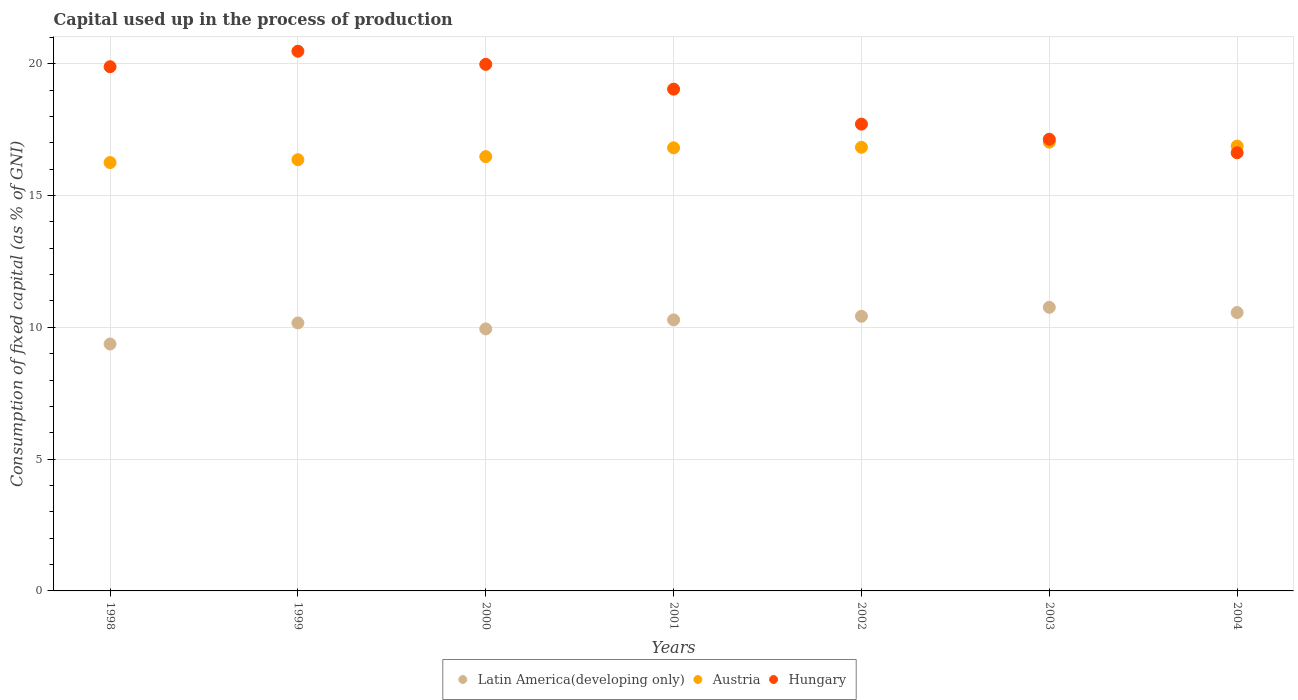How many different coloured dotlines are there?
Give a very brief answer. 3. Is the number of dotlines equal to the number of legend labels?
Ensure brevity in your answer.  Yes. What is the capital used up in the process of production in Austria in 1998?
Give a very brief answer. 16.25. Across all years, what is the maximum capital used up in the process of production in Hungary?
Your response must be concise. 20.47. Across all years, what is the minimum capital used up in the process of production in Austria?
Give a very brief answer. 16.25. In which year was the capital used up in the process of production in Latin America(developing only) minimum?
Your answer should be compact. 1998. What is the total capital used up in the process of production in Latin America(developing only) in the graph?
Make the answer very short. 71.49. What is the difference between the capital used up in the process of production in Hungary in 1999 and that in 2002?
Your response must be concise. 2.77. What is the difference between the capital used up in the process of production in Austria in 2002 and the capital used up in the process of production in Latin America(developing only) in 1999?
Provide a succinct answer. 6.66. What is the average capital used up in the process of production in Hungary per year?
Make the answer very short. 18.69. In the year 2003, what is the difference between the capital used up in the process of production in Austria and capital used up in the process of production in Latin America(developing only)?
Offer a very short reply. 6.27. In how many years, is the capital used up in the process of production in Latin America(developing only) greater than 6 %?
Make the answer very short. 7. What is the ratio of the capital used up in the process of production in Austria in 2000 to that in 2002?
Ensure brevity in your answer.  0.98. Is the capital used up in the process of production in Hungary in 2000 less than that in 2003?
Make the answer very short. No. What is the difference between the highest and the second highest capital used up in the process of production in Hungary?
Provide a succinct answer. 0.5. What is the difference between the highest and the lowest capital used up in the process of production in Austria?
Offer a terse response. 0.77. In how many years, is the capital used up in the process of production in Latin America(developing only) greater than the average capital used up in the process of production in Latin America(developing only) taken over all years?
Give a very brief answer. 4. Is it the case that in every year, the sum of the capital used up in the process of production in Austria and capital used up in the process of production in Latin America(developing only)  is greater than the capital used up in the process of production in Hungary?
Make the answer very short. Yes. How many legend labels are there?
Keep it short and to the point. 3. How are the legend labels stacked?
Offer a very short reply. Horizontal. What is the title of the graph?
Your answer should be compact. Capital used up in the process of production. Does "Least developed countries" appear as one of the legend labels in the graph?
Your response must be concise. No. What is the label or title of the X-axis?
Provide a short and direct response. Years. What is the label or title of the Y-axis?
Provide a short and direct response. Consumption of fixed capital (as % of GNI). What is the Consumption of fixed capital (as % of GNI) in Latin America(developing only) in 1998?
Offer a terse response. 9.37. What is the Consumption of fixed capital (as % of GNI) of Austria in 1998?
Give a very brief answer. 16.25. What is the Consumption of fixed capital (as % of GNI) in Hungary in 1998?
Ensure brevity in your answer.  19.89. What is the Consumption of fixed capital (as % of GNI) of Latin America(developing only) in 1999?
Offer a very short reply. 10.17. What is the Consumption of fixed capital (as % of GNI) in Austria in 1999?
Make the answer very short. 16.36. What is the Consumption of fixed capital (as % of GNI) in Hungary in 1999?
Your answer should be compact. 20.47. What is the Consumption of fixed capital (as % of GNI) of Latin America(developing only) in 2000?
Make the answer very short. 9.94. What is the Consumption of fixed capital (as % of GNI) in Austria in 2000?
Provide a short and direct response. 16.48. What is the Consumption of fixed capital (as % of GNI) of Hungary in 2000?
Ensure brevity in your answer.  19.98. What is the Consumption of fixed capital (as % of GNI) of Latin America(developing only) in 2001?
Your answer should be compact. 10.28. What is the Consumption of fixed capital (as % of GNI) in Austria in 2001?
Offer a terse response. 16.81. What is the Consumption of fixed capital (as % of GNI) in Hungary in 2001?
Make the answer very short. 19.04. What is the Consumption of fixed capital (as % of GNI) in Latin America(developing only) in 2002?
Make the answer very short. 10.42. What is the Consumption of fixed capital (as % of GNI) in Austria in 2002?
Provide a succinct answer. 16.83. What is the Consumption of fixed capital (as % of GNI) of Hungary in 2002?
Give a very brief answer. 17.71. What is the Consumption of fixed capital (as % of GNI) in Latin America(developing only) in 2003?
Ensure brevity in your answer.  10.76. What is the Consumption of fixed capital (as % of GNI) of Austria in 2003?
Keep it short and to the point. 17.02. What is the Consumption of fixed capital (as % of GNI) of Hungary in 2003?
Keep it short and to the point. 17.14. What is the Consumption of fixed capital (as % of GNI) in Latin America(developing only) in 2004?
Provide a short and direct response. 10.56. What is the Consumption of fixed capital (as % of GNI) in Austria in 2004?
Make the answer very short. 16.88. What is the Consumption of fixed capital (as % of GNI) in Hungary in 2004?
Offer a very short reply. 16.62. Across all years, what is the maximum Consumption of fixed capital (as % of GNI) in Latin America(developing only)?
Make the answer very short. 10.76. Across all years, what is the maximum Consumption of fixed capital (as % of GNI) in Austria?
Offer a terse response. 17.02. Across all years, what is the maximum Consumption of fixed capital (as % of GNI) in Hungary?
Make the answer very short. 20.47. Across all years, what is the minimum Consumption of fixed capital (as % of GNI) in Latin America(developing only)?
Provide a short and direct response. 9.37. Across all years, what is the minimum Consumption of fixed capital (as % of GNI) of Austria?
Keep it short and to the point. 16.25. Across all years, what is the minimum Consumption of fixed capital (as % of GNI) of Hungary?
Your answer should be very brief. 16.62. What is the total Consumption of fixed capital (as % of GNI) in Latin America(developing only) in the graph?
Give a very brief answer. 71.49. What is the total Consumption of fixed capital (as % of GNI) of Austria in the graph?
Offer a very short reply. 116.62. What is the total Consumption of fixed capital (as % of GNI) in Hungary in the graph?
Ensure brevity in your answer.  130.84. What is the difference between the Consumption of fixed capital (as % of GNI) of Latin America(developing only) in 1998 and that in 1999?
Your response must be concise. -0.8. What is the difference between the Consumption of fixed capital (as % of GNI) in Austria in 1998 and that in 1999?
Make the answer very short. -0.11. What is the difference between the Consumption of fixed capital (as % of GNI) in Hungary in 1998 and that in 1999?
Keep it short and to the point. -0.59. What is the difference between the Consumption of fixed capital (as % of GNI) in Latin America(developing only) in 1998 and that in 2000?
Make the answer very short. -0.57. What is the difference between the Consumption of fixed capital (as % of GNI) in Austria in 1998 and that in 2000?
Your answer should be compact. -0.22. What is the difference between the Consumption of fixed capital (as % of GNI) in Hungary in 1998 and that in 2000?
Your response must be concise. -0.09. What is the difference between the Consumption of fixed capital (as % of GNI) in Latin America(developing only) in 1998 and that in 2001?
Your answer should be compact. -0.91. What is the difference between the Consumption of fixed capital (as % of GNI) in Austria in 1998 and that in 2001?
Keep it short and to the point. -0.56. What is the difference between the Consumption of fixed capital (as % of GNI) of Hungary in 1998 and that in 2001?
Your answer should be very brief. 0.85. What is the difference between the Consumption of fixed capital (as % of GNI) of Latin America(developing only) in 1998 and that in 2002?
Keep it short and to the point. -1.05. What is the difference between the Consumption of fixed capital (as % of GNI) in Austria in 1998 and that in 2002?
Keep it short and to the point. -0.58. What is the difference between the Consumption of fixed capital (as % of GNI) of Hungary in 1998 and that in 2002?
Provide a succinct answer. 2.18. What is the difference between the Consumption of fixed capital (as % of GNI) of Latin America(developing only) in 1998 and that in 2003?
Your answer should be very brief. -1.39. What is the difference between the Consumption of fixed capital (as % of GNI) in Austria in 1998 and that in 2003?
Provide a succinct answer. -0.77. What is the difference between the Consumption of fixed capital (as % of GNI) in Hungary in 1998 and that in 2003?
Provide a short and direct response. 2.75. What is the difference between the Consumption of fixed capital (as % of GNI) of Latin America(developing only) in 1998 and that in 2004?
Ensure brevity in your answer.  -1.19. What is the difference between the Consumption of fixed capital (as % of GNI) in Austria in 1998 and that in 2004?
Your answer should be very brief. -0.62. What is the difference between the Consumption of fixed capital (as % of GNI) in Hungary in 1998 and that in 2004?
Keep it short and to the point. 3.26. What is the difference between the Consumption of fixed capital (as % of GNI) in Latin America(developing only) in 1999 and that in 2000?
Your answer should be very brief. 0.23. What is the difference between the Consumption of fixed capital (as % of GNI) of Austria in 1999 and that in 2000?
Your response must be concise. -0.12. What is the difference between the Consumption of fixed capital (as % of GNI) of Hungary in 1999 and that in 2000?
Provide a short and direct response. 0.5. What is the difference between the Consumption of fixed capital (as % of GNI) of Latin America(developing only) in 1999 and that in 2001?
Provide a short and direct response. -0.12. What is the difference between the Consumption of fixed capital (as % of GNI) in Austria in 1999 and that in 2001?
Offer a very short reply. -0.45. What is the difference between the Consumption of fixed capital (as % of GNI) in Hungary in 1999 and that in 2001?
Provide a short and direct response. 1.44. What is the difference between the Consumption of fixed capital (as % of GNI) in Latin America(developing only) in 1999 and that in 2002?
Ensure brevity in your answer.  -0.25. What is the difference between the Consumption of fixed capital (as % of GNI) in Austria in 1999 and that in 2002?
Your answer should be compact. -0.47. What is the difference between the Consumption of fixed capital (as % of GNI) of Hungary in 1999 and that in 2002?
Give a very brief answer. 2.77. What is the difference between the Consumption of fixed capital (as % of GNI) in Latin America(developing only) in 1999 and that in 2003?
Ensure brevity in your answer.  -0.59. What is the difference between the Consumption of fixed capital (as % of GNI) of Austria in 1999 and that in 2003?
Keep it short and to the point. -0.67. What is the difference between the Consumption of fixed capital (as % of GNI) of Hungary in 1999 and that in 2003?
Offer a very short reply. 3.34. What is the difference between the Consumption of fixed capital (as % of GNI) in Latin America(developing only) in 1999 and that in 2004?
Ensure brevity in your answer.  -0.39. What is the difference between the Consumption of fixed capital (as % of GNI) in Austria in 1999 and that in 2004?
Your answer should be compact. -0.52. What is the difference between the Consumption of fixed capital (as % of GNI) in Hungary in 1999 and that in 2004?
Make the answer very short. 3.85. What is the difference between the Consumption of fixed capital (as % of GNI) of Latin America(developing only) in 2000 and that in 2001?
Your answer should be compact. -0.34. What is the difference between the Consumption of fixed capital (as % of GNI) of Austria in 2000 and that in 2001?
Give a very brief answer. -0.33. What is the difference between the Consumption of fixed capital (as % of GNI) in Hungary in 2000 and that in 2001?
Give a very brief answer. 0.94. What is the difference between the Consumption of fixed capital (as % of GNI) of Latin America(developing only) in 2000 and that in 2002?
Your answer should be compact. -0.48. What is the difference between the Consumption of fixed capital (as % of GNI) in Austria in 2000 and that in 2002?
Provide a short and direct response. -0.35. What is the difference between the Consumption of fixed capital (as % of GNI) of Hungary in 2000 and that in 2002?
Give a very brief answer. 2.27. What is the difference between the Consumption of fixed capital (as % of GNI) of Latin America(developing only) in 2000 and that in 2003?
Your answer should be compact. -0.82. What is the difference between the Consumption of fixed capital (as % of GNI) in Austria in 2000 and that in 2003?
Your response must be concise. -0.55. What is the difference between the Consumption of fixed capital (as % of GNI) of Hungary in 2000 and that in 2003?
Offer a terse response. 2.84. What is the difference between the Consumption of fixed capital (as % of GNI) in Latin America(developing only) in 2000 and that in 2004?
Provide a succinct answer. -0.62. What is the difference between the Consumption of fixed capital (as % of GNI) of Austria in 2000 and that in 2004?
Make the answer very short. -0.4. What is the difference between the Consumption of fixed capital (as % of GNI) of Hungary in 2000 and that in 2004?
Make the answer very short. 3.35. What is the difference between the Consumption of fixed capital (as % of GNI) in Latin America(developing only) in 2001 and that in 2002?
Offer a very short reply. -0.14. What is the difference between the Consumption of fixed capital (as % of GNI) of Austria in 2001 and that in 2002?
Offer a terse response. -0.02. What is the difference between the Consumption of fixed capital (as % of GNI) of Hungary in 2001 and that in 2002?
Your response must be concise. 1.33. What is the difference between the Consumption of fixed capital (as % of GNI) of Latin America(developing only) in 2001 and that in 2003?
Give a very brief answer. -0.48. What is the difference between the Consumption of fixed capital (as % of GNI) of Austria in 2001 and that in 2003?
Keep it short and to the point. -0.21. What is the difference between the Consumption of fixed capital (as % of GNI) in Hungary in 2001 and that in 2003?
Provide a succinct answer. 1.9. What is the difference between the Consumption of fixed capital (as % of GNI) of Latin America(developing only) in 2001 and that in 2004?
Keep it short and to the point. -0.28. What is the difference between the Consumption of fixed capital (as % of GNI) in Austria in 2001 and that in 2004?
Make the answer very short. -0.07. What is the difference between the Consumption of fixed capital (as % of GNI) of Hungary in 2001 and that in 2004?
Give a very brief answer. 2.41. What is the difference between the Consumption of fixed capital (as % of GNI) of Latin America(developing only) in 2002 and that in 2003?
Your answer should be very brief. -0.34. What is the difference between the Consumption of fixed capital (as % of GNI) of Austria in 2002 and that in 2003?
Provide a succinct answer. -0.19. What is the difference between the Consumption of fixed capital (as % of GNI) in Hungary in 2002 and that in 2003?
Your response must be concise. 0.57. What is the difference between the Consumption of fixed capital (as % of GNI) of Latin America(developing only) in 2002 and that in 2004?
Ensure brevity in your answer.  -0.14. What is the difference between the Consumption of fixed capital (as % of GNI) of Austria in 2002 and that in 2004?
Make the answer very short. -0.05. What is the difference between the Consumption of fixed capital (as % of GNI) of Hungary in 2002 and that in 2004?
Make the answer very short. 1.09. What is the difference between the Consumption of fixed capital (as % of GNI) of Latin America(developing only) in 2003 and that in 2004?
Your answer should be very brief. 0.2. What is the difference between the Consumption of fixed capital (as % of GNI) of Austria in 2003 and that in 2004?
Give a very brief answer. 0.15. What is the difference between the Consumption of fixed capital (as % of GNI) of Hungary in 2003 and that in 2004?
Your response must be concise. 0.51. What is the difference between the Consumption of fixed capital (as % of GNI) in Latin America(developing only) in 1998 and the Consumption of fixed capital (as % of GNI) in Austria in 1999?
Make the answer very short. -6.99. What is the difference between the Consumption of fixed capital (as % of GNI) in Latin America(developing only) in 1998 and the Consumption of fixed capital (as % of GNI) in Hungary in 1999?
Provide a short and direct response. -11.11. What is the difference between the Consumption of fixed capital (as % of GNI) in Austria in 1998 and the Consumption of fixed capital (as % of GNI) in Hungary in 1999?
Provide a succinct answer. -4.22. What is the difference between the Consumption of fixed capital (as % of GNI) in Latin America(developing only) in 1998 and the Consumption of fixed capital (as % of GNI) in Austria in 2000?
Offer a terse response. -7.11. What is the difference between the Consumption of fixed capital (as % of GNI) in Latin America(developing only) in 1998 and the Consumption of fixed capital (as % of GNI) in Hungary in 2000?
Ensure brevity in your answer.  -10.61. What is the difference between the Consumption of fixed capital (as % of GNI) of Austria in 1998 and the Consumption of fixed capital (as % of GNI) of Hungary in 2000?
Your answer should be very brief. -3.73. What is the difference between the Consumption of fixed capital (as % of GNI) in Latin America(developing only) in 1998 and the Consumption of fixed capital (as % of GNI) in Austria in 2001?
Your answer should be compact. -7.44. What is the difference between the Consumption of fixed capital (as % of GNI) of Latin America(developing only) in 1998 and the Consumption of fixed capital (as % of GNI) of Hungary in 2001?
Your answer should be very brief. -9.67. What is the difference between the Consumption of fixed capital (as % of GNI) of Austria in 1998 and the Consumption of fixed capital (as % of GNI) of Hungary in 2001?
Offer a very short reply. -2.78. What is the difference between the Consumption of fixed capital (as % of GNI) in Latin America(developing only) in 1998 and the Consumption of fixed capital (as % of GNI) in Austria in 2002?
Provide a succinct answer. -7.46. What is the difference between the Consumption of fixed capital (as % of GNI) of Latin America(developing only) in 1998 and the Consumption of fixed capital (as % of GNI) of Hungary in 2002?
Your response must be concise. -8.34. What is the difference between the Consumption of fixed capital (as % of GNI) in Austria in 1998 and the Consumption of fixed capital (as % of GNI) in Hungary in 2002?
Provide a short and direct response. -1.46. What is the difference between the Consumption of fixed capital (as % of GNI) in Latin America(developing only) in 1998 and the Consumption of fixed capital (as % of GNI) in Austria in 2003?
Offer a terse response. -7.66. What is the difference between the Consumption of fixed capital (as % of GNI) of Latin America(developing only) in 1998 and the Consumption of fixed capital (as % of GNI) of Hungary in 2003?
Give a very brief answer. -7.77. What is the difference between the Consumption of fixed capital (as % of GNI) in Austria in 1998 and the Consumption of fixed capital (as % of GNI) in Hungary in 2003?
Make the answer very short. -0.88. What is the difference between the Consumption of fixed capital (as % of GNI) of Latin America(developing only) in 1998 and the Consumption of fixed capital (as % of GNI) of Austria in 2004?
Provide a short and direct response. -7.51. What is the difference between the Consumption of fixed capital (as % of GNI) in Latin America(developing only) in 1998 and the Consumption of fixed capital (as % of GNI) in Hungary in 2004?
Keep it short and to the point. -7.26. What is the difference between the Consumption of fixed capital (as % of GNI) of Austria in 1998 and the Consumption of fixed capital (as % of GNI) of Hungary in 2004?
Offer a terse response. -0.37. What is the difference between the Consumption of fixed capital (as % of GNI) in Latin America(developing only) in 1999 and the Consumption of fixed capital (as % of GNI) in Austria in 2000?
Offer a very short reply. -6.31. What is the difference between the Consumption of fixed capital (as % of GNI) in Latin America(developing only) in 1999 and the Consumption of fixed capital (as % of GNI) in Hungary in 2000?
Your answer should be very brief. -9.81. What is the difference between the Consumption of fixed capital (as % of GNI) of Austria in 1999 and the Consumption of fixed capital (as % of GNI) of Hungary in 2000?
Ensure brevity in your answer.  -3.62. What is the difference between the Consumption of fixed capital (as % of GNI) of Latin America(developing only) in 1999 and the Consumption of fixed capital (as % of GNI) of Austria in 2001?
Offer a very short reply. -6.64. What is the difference between the Consumption of fixed capital (as % of GNI) of Latin America(developing only) in 1999 and the Consumption of fixed capital (as % of GNI) of Hungary in 2001?
Offer a terse response. -8.87. What is the difference between the Consumption of fixed capital (as % of GNI) in Austria in 1999 and the Consumption of fixed capital (as % of GNI) in Hungary in 2001?
Give a very brief answer. -2.68. What is the difference between the Consumption of fixed capital (as % of GNI) in Latin America(developing only) in 1999 and the Consumption of fixed capital (as % of GNI) in Austria in 2002?
Your response must be concise. -6.66. What is the difference between the Consumption of fixed capital (as % of GNI) in Latin America(developing only) in 1999 and the Consumption of fixed capital (as % of GNI) in Hungary in 2002?
Your answer should be very brief. -7.54. What is the difference between the Consumption of fixed capital (as % of GNI) in Austria in 1999 and the Consumption of fixed capital (as % of GNI) in Hungary in 2002?
Your answer should be compact. -1.35. What is the difference between the Consumption of fixed capital (as % of GNI) in Latin America(developing only) in 1999 and the Consumption of fixed capital (as % of GNI) in Austria in 2003?
Your answer should be very brief. -6.86. What is the difference between the Consumption of fixed capital (as % of GNI) of Latin America(developing only) in 1999 and the Consumption of fixed capital (as % of GNI) of Hungary in 2003?
Provide a succinct answer. -6.97. What is the difference between the Consumption of fixed capital (as % of GNI) of Austria in 1999 and the Consumption of fixed capital (as % of GNI) of Hungary in 2003?
Give a very brief answer. -0.78. What is the difference between the Consumption of fixed capital (as % of GNI) of Latin America(developing only) in 1999 and the Consumption of fixed capital (as % of GNI) of Austria in 2004?
Provide a short and direct response. -6.71. What is the difference between the Consumption of fixed capital (as % of GNI) in Latin America(developing only) in 1999 and the Consumption of fixed capital (as % of GNI) in Hungary in 2004?
Give a very brief answer. -6.46. What is the difference between the Consumption of fixed capital (as % of GNI) in Austria in 1999 and the Consumption of fixed capital (as % of GNI) in Hungary in 2004?
Keep it short and to the point. -0.26. What is the difference between the Consumption of fixed capital (as % of GNI) in Latin America(developing only) in 2000 and the Consumption of fixed capital (as % of GNI) in Austria in 2001?
Give a very brief answer. -6.87. What is the difference between the Consumption of fixed capital (as % of GNI) in Latin America(developing only) in 2000 and the Consumption of fixed capital (as % of GNI) in Hungary in 2001?
Your response must be concise. -9.1. What is the difference between the Consumption of fixed capital (as % of GNI) of Austria in 2000 and the Consumption of fixed capital (as % of GNI) of Hungary in 2001?
Ensure brevity in your answer.  -2.56. What is the difference between the Consumption of fixed capital (as % of GNI) in Latin America(developing only) in 2000 and the Consumption of fixed capital (as % of GNI) in Austria in 2002?
Your answer should be compact. -6.89. What is the difference between the Consumption of fixed capital (as % of GNI) of Latin America(developing only) in 2000 and the Consumption of fixed capital (as % of GNI) of Hungary in 2002?
Your answer should be very brief. -7.77. What is the difference between the Consumption of fixed capital (as % of GNI) of Austria in 2000 and the Consumption of fixed capital (as % of GNI) of Hungary in 2002?
Your answer should be compact. -1.23. What is the difference between the Consumption of fixed capital (as % of GNI) of Latin America(developing only) in 2000 and the Consumption of fixed capital (as % of GNI) of Austria in 2003?
Your response must be concise. -7.08. What is the difference between the Consumption of fixed capital (as % of GNI) in Latin America(developing only) in 2000 and the Consumption of fixed capital (as % of GNI) in Hungary in 2003?
Give a very brief answer. -7.2. What is the difference between the Consumption of fixed capital (as % of GNI) in Austria in 2000 and the Consumption of fixed capital (as % of GNI) in Hungary in 2003?
Ensure brevity in your answer.  -0.66. What is the difference between the Consumption of fixed capital (as % of GNI) in Latin America(developing only) in 2000 and the Consumption of fixed capital (as % of GNI) in Austria in 2004?
Offer a very short reply. -6.94. What is the difference between the Consumption of fixed capital (as % of GNI) of Latin America(developing only) in 2000 and the Consumption of fixed capital (as % of GNI) of Hungary in 2004?
Your answer should be compact. -6.68. What is the difference between the Consumption of fixed capital (as % of GNI) in Austria in 2000 and the Consumption of fixed capital (as % of GNI) in Hungary in 2004?
Provide a succinct answer. -0.15. What is the difference between the Consumption of fixed capital (as % of GNI) of Latin America(developing only) in 2001 and the Consumption of fixed capital (as % of GNI) of Austria in 2002?
Ensure brevity in your answer.  -6.55. What is the difference between the Consumption of fixed capital (as % of GNI) in Latin America(developing only) in 2001 and the Consumption of fixed capital (as % of GNI) in Hungary in 2002?
Make the answer very short. -7.43. What is the difference between the Consumption of fixed capital (as % of GNI) in Austria in 2001 and the Consumption of fixed capital (as % of GNI) in Hungary in 2002?
Give a very brief answer. -0.9. What is the difference between the Consumption of fixed capital (as % of GNI) of Latin America(developing only) in 2001 and the Consumption of fixed capital (as % of GNI) of Austria in 2003?
Provide a succinct answer. -6.74. What is the difference between the Consumption of fixed capital (as % of GNI) of Latin America(developing only) in 2001 and the Consumption of fixed capital (as % of GNI) of Hungary in 2003?
Offer a terse response. -6.85. What is the difference between the Consumption of fixed capital (as % of GNI) of Austria in 2001 and the Consumption of fixed capital (as % of GNI) of Hungary in 2003?
Your answer should be compact. -0.33. What is the difference between the Consumption of fixed capital (as % of GNI) in Latin America(developing only) in 2001 and the Consumption of fixed capital (as % of GNI) in Austria in 2004?
Ensure brevity in your answer.  -6.59. What is the difference between the Consumption of fixed capital (as % of GNI) of Latin America(developing only) in 2001 and the Consumption of fixed capital (as % of GNI) of Hungary in 2004?
Offer a terse response. -6.34. What is the difference between the Consumption of fixed capital (as % of GNI) in Austria in 2001 and the Consumption of fixed capital (as % of GNI) in Hungary in 2004?
Your answer should be compact. 0.19. What is the difference between the Consumption of fixed capital (as % of GNI) of Latin America(developing only) in 2002 and the Consumption of fixed capital (as % of GNI) of Austria in 2003?
Keep it short and to the point. -6.61. What is the difference between the Consumption of fixed capital (as % of GNI) in Latin America(developing only) in 2002 and the Consumption of fixed capital (as % of GNI) in Hungary in 2003?
Your response must be concise. -6.72. What is the difference between the Consumption of fixed capital (as % of GNI) in Austria in 2002 and the Consumption of fixed capital (as % of GNI) in Hungary in 2003?
Offer a terse response. -0.31. What is the difference between the Consumption of fixed capital (as % of GNI) in Latin America(developing only) in 2002 and the Consumption of fixed capital (as % of GNI) in Austria in 2004?
Provide a succinct answer. -6.46. What is the difference between the Consumption of fixed capital (as % of GNI) in Latin America(developing only) in 2002 and the Consumption of fixed capital (as % of GNI) in Hungary in 2004?
Give a very brief answer. -6.2. What is the difference between the Consumption of fixed capital (as % of GNI) in Austria in 2002 and the Consumption of fixed capital (as % of GNI) in Hungary in 2004?
Ensure brevity in your answer.  0.21. What is the difference between the Consumption of fixed capital (as % of GNI) in Latin America(developing only) in 2003 and the Consumption of fixed capital (as % of GNI) in Austria in 2004?
Your answer should be compact. -6.12. What is the difference between the Consumption of fixed capital (as % of GNI) of Latin America(developing only) in 2003 and the Consumption of fixed capital (as % of GNI) of Hungary in 2004?
Provide a short and direct response. -5.86. What is the difference between the Consumption of fixed capital (as % of GNI) of Austria in 2003 and the Consumption of fixed capital (as % of GNI) of Hungary in 2004?
Offer a very short reply. 0.4. What is the average Consumption of fixed capital (as % of GNI) in Latin America(developing only) per year?
Ensure brevity in your answer.  10.21. What is the average Consumption of fixed capital (as % of GNI) of Austria per year?
Make the answer very short. 16.66. What is the average Consumption of fixed capital (as % of GNI) in Hungary per year?
Offer a terse response. 18.69. In the year 1998, what is the difference between the Consumption of fixed capital (as % of GNI) of Latin America(developing only) and Consumption of fixed capital (as % of GNI) of Austria?
Offer a very short reply. -6.88. In the year 1998, what is the difference between the Consumption of fixed capital (as % of GNI) of Latin America(developing only) and Consumption of fixed capital (as % of GNI) of Hungary?
Provide a short and direct response. -10.52. In the year 1998, what is the difference between the Consumption of fixed capital (as % of GNI) in Austria and Consumption of fixed capital (as % of GNI) in Hungary?
Give a very brief answer. -3.64. In the year 1999, what is the difference between the Consumption of fixed capital (as % of GNI) in Latin America(developing only) and Consumption of fixed capital (as % of GNI) in Austria?
Your response must be concise. -6.19. In the year 1999, what is the difference between the Consumption of fixed capital (as % of GNI) of Latin America(developing only) and Consumption of fixed capital (as % of GNI) of Hungary?
Keep it short and to the point. -10.31. In the year 1999, what is the difference between the Consumption of fixed capital (as % of GNI) in Austria and Consumption of fixed capital (as % of GNI) in Hungary?
Provide a succinct answer. -4.12. In the year 2000, what is the difference between the Consumption of fixed capital (as % of GNI) in Latin America(developing only) and Consumption of fixed capital (as % of GNI) in Austria?
Keep it short and to the point. -6.54. In the year 2000, what is the difference between the Consumption of fixed capital (as % of GNI) in Latin America(developing only) and Consumption of fixed capital (as % of GNI) in Hungary?
Your answer should be compact. -10.04. In the year 2000, what is the difference between the Consumption of fixed capital (as % of GNI) in Austria and Consumption of fixed capital (as % of GNI) in Hungary?
Your answer should be very brief. -3.5. In the year 2001, what is the difference between the Consumption of fixed capital (as % of GNI) in Latin America(developing only) and Consumption of fixed capital (as % of GNI) in Austria?
Provide a short and direct response. -6.53. In the year 2001, what is the difference between the Consumption of fixed capital (as % of GNI) of Latin America(developing only) and Consumption of fixed capital (as % of GNI) of Hungary?
Keep it short and to the point. -8.75. In the year 2001, what is the difference between the Consumption of fixed capital (as % of GNI) of Austria and Consumption of fixed capital (as % of GNI) of Hungary?
Offer a very short reply. -2.23. In the year 2002, what is the difference between the Consumption of fixed capital (as % of GNI) of Latin America(developing only) and Consumption of fixed capital (as % of GNI) of Austria?
Make the answer very short. -6.41. In the year 2002, what is the difference between the Consumption of fixed capital (as % of GNI) of Latin America(developing only) and Consumption of fixed capital (as % of GNI) of Hungary?
Provide a succinct answer. -7.29. In the year 2002, what is the difference between the Consumption of fixed capital (as % of GNI) in Austria and Consumption of fixed capital (as % of GNI) in Hungary?
Keep it short and to the point. -0.88. In the year 2003, what is the difference between the Consumption of fixed capital (as % of GNI) of Latin America(developing only) and Consumption of fixed capital (as % of GNI) of Austria?
Your answer should be very brief. -6.27. In the year 2003, what is the difference between the Consumption of fixed capital (as % of GNI) of Latin America(developing only) and Consumption of fixed capital (as % of GNI) of Hungary?
Your response must be concise. -6.38. In the year 2003, what is the difference between the Consumption of fixed capital (as % of GNI) in Austria and Consumption of fixed capital (as % of GNI) in Hungary?
Give a very brief answer. -0.11. In the year 2004, what is the difference between the Consumption of fixed capital (as % of GNI) of Latin America(developing only) and Consumption of fixed capital (as % of GNI) of Austria?
Provide a short and direct response. -6.32. In the year 2004, what is the difference between the Consumption of fixed capital (as % of GNI) of Latin America(developing only) and Consumption of fixed capital (as % of GNI) of Hungary?
Provide a short and direct response. -6.06. In the year 2004, what is the difference between the Consumption of fixed capital (as % of GNI) in Austria and Consumption of fixed capital (as % of GNI) in Hungary?
Keep it short and to the point. 0.25. What is the ratio of the Consumption of fixed capital (as % of GNI) of Latin America(developing only) in 1998 to that in 1999?
Your answer should be compact. 0.92. What is the ratio of the Consumption of fixed capital (as % of GNI) of Hungary in 1998 to that in 1999?
Your answer should be very brief. 0.97. What is the ratio of the Consumption of fixed capital (as % of GNI) in Latin America(developing only) in 1998 to that in 2000?
Your response must be concise. 0.94. What is the ratio of the Consumption of fixed capital (as % of GNI) in Austria in 1998 to that in 2000?
Offer a very short reply. 0.99. What is the ratio of the Consumption of fixed capital (as % of GNI) in Hungary in 1998 to that in 2000?
Ensure brevity in your answer.  1. What is the ratio of the Consumption of fixed capital (as % of GNI) in Latin America(developing only) in 1998 to that in 2001?
Offer a terse response. 0.91. What is the ratio of the Consumption of fixed capital (as % of GNI) of Austria in 1998 to that in 2001?
Give a very brief answer. 0.97. What is the ratio of the Consumption of fixed capital (as % of GNI) in Hungary in 1998 to that in 2001?
Your answer should be very brief. 1.04. What is the ratio of the Consumption of fixed capital (as % of GNI) of Latin America(developing only) in 1998 to that in 2002?
Offer a very short reply. 0.9. What is the ratio of the Consumption of fixed capital (as % of GNI) of Austria in 1998 to that in 2002?
Offer a terse response. 0.97. What is the ratio of the Consumption of fixed capital (as % of GNI) of Hungary in 1998 to that in 2002?
Offer a very short reply. 1.12. What is the ratio of the Consumption of fixed capital (as % of GNI) of Latin America(developing only) in 1998 to that in 2003?
Keep it short and to the point. 0.87. What is the ratio of the Consumption of fixed capital (as % of GNI) in Austria in 1998 to that in 2003?
Your answer should be compact. 0.95. What is the ratio of the Consumption of fixed capital (as % of GNI) in Hungary in 1998 to that in 2003?
Your response must be concise. 1.16. What is the ratio of the Consumption of fixed capital (as % of GNI) of Latin America(developing only) in 1998 to that in 2004?
Give a very brief answer. 0.89. What is the ratio of the Consumption of fixed capital (as % of GNI) in Austria in 1998 to that in 2004?
Make the answer very short. 0.96. What is the ratio of the Consumption of fixed capital (as % of GNI) in Hungary in 1998 to that in 2004?
Make the answer very short. 1.2. What is the ratio of the Consumption of fixed capital (as % of GNI) in Latin America(developing only) in 1999 to that in 2000?
Your answer should be compact. 1.02. What is the ratio of the Consumption of fixed capital (as % of GNI) of Hungary in 1999 to that in 2000?
Your answer should be very brief. 1.02. What is the ratio of the Consumption of fixed capital (as % of GNI) of Austria in 1999 to that in 2001?
Your answer should be very brief. 0.97. What is the ratio of the Consumption of fixed capital (as % of GNI) of Hungary in 1999 to that in 2001?
Offer a terse response. 1.08. What is the ratio of the Consumption of fixed capital (as % of GNI) in Latin America(developing only) in 1999 to that in 2002?
Provide a succinct answer. 0.98. What is the ratio of the Consumption of fixed capital (as % of GNI) of Hungary in 1999 to that in 2002?
Make the answer very short. 1.16. What is the ratio of the Consumption of fixed capital (as % of GNI) in Latin America(developing only) in 1999 to that in 2003?
Provide a short and direct response. 0.94. What is the ratio of the Consumption of fixed capital (as % of GNI) in Austria in 1999 to that in 2003?
Ensure brevity in your answer.  0.96. What is the ratio of the Consumption of fixed capital (as % of GNI) of Hungary in 1999 to that in 2003?
Offer a very short reply. 1.19. What is the ratio of the Consumption of fixed capital (as % of GNI) of Latin America(developing only) in 1999 to that in 2004?
Give a very brief answer. 0.96. What is the ratio of the Consumption of fixed capital (as % of GNI) of Austria in 1999 to that in 2004?
Your answer should be very brief. 0.97. What is the ratio of the Consumption of fixed capital (as % of GNI) of Hungary in 1999 to that in 2004?
Make the answer very short. 1.23. What is the ratio of the Consumption of fixed capital (as % of GNI) in Latin America(developing only) in 2000 to that in 2001?
Your response must be concise. 0.97. What is the ratio of the Consumption of fixed capital (as % of GNI) in Austria in 2000 to that in 2001?
Your answer should be compact. 0.98. What is the ratio of the Consumption of fixed capital (as % of GNI) of Hungary in 2000 to that in 2001?
Offer a very short reply. 1.05. What is the ratio of the Consumption of fixed capital (as % of GNI) in Latin America(developing only) in 2000 to that in 2002?
Your response must be concise. 0.95. What is the ratio of the Consumption of fixed capital (as % of GNI) in Austria in 2000 to that in 2002?
Offer a very short reply. 0.98. What is the ratio of the Consumption of fixed capital (as % of GNI) of Hungary in 2000 to that in 2002?
Your answer should be very brief. 1.13. What is the ratio of the Consumption of fixed capital (as % of GNI) of Latin America(developing only) in 2000 to that in 2003?
Your answer should be very brief. 0.92. What is the ratio of the Consumption of fixed capital (as % of GNI) in Austria in 2000 to that in 2003?
Offer a terse response. 0.97. What is the ratio of the Consumption of fixed capital (as % of GNI) in Hungary in 2000 to that in 2003?
Give a very brief answer. 1.17. What is the ratio of the Consumption of fixed capital (as % of GNI) in Latin America(developing only) in 2000 to that in 2004?
Offer a very short reply. 0.94. What is the ratio of the Consumption of fixed capital (as % of GNI) of Austria in 2000 to that in 2004?
Give a very brief answer. 0.98. What is the ratio of the Consumption of fixed capital (as % of GNI) of Hungary in 2000 to that in 2004?
Make the answer very short. 1.2. What is the ratio of the Consumption of fixed capital (as % of GNI) of Latin America(developing only) in 2001 to that in 2002?
Make the answer very short. 0.99. What is the ratio of the Consumption of fixed capital (as % of GNI) in Hungary in 2001 to that in 2002?
Provide a succinct answer. 1.07. What is the ratio of the Consumption of fixed capital (as % of GNI) in Latin America(developing only) in 2001 to that in 2003?
Your answer should be very brief. 0.96. What is the ratio of the Consumption of fixed capital (as % of GNI) in Austria in 2001 to that in 2003?
Your answer should be very brief. 0.99. What is the ratio of the Consumption of fixed capital (as % of GNI) of Hungary in 2001 to that in 2003?
Offer a very short reply. 1.11. What is the ratio of the Consumption of fixed capital (as % of GNI) of Latin America(developing only) in 2001 to that in 2004?
Give a very brief answer. 0.97. What is the ratio of the Consumption of fixed capital (as % of GNI) in Hungary in 2001 to that in 2004?
Keep it short and to the point. 1.15. What is the ratio of the Consumption of fixed capital (as % of GNI) of Latin America(developing only) in 2002 to that in 2003?
Make the answer very short. 0.97. What is the ratio of the Consumption of fixed capital (as % of GNI) in Austria in 2002 to that in 2003?
Ensure brevity in your answer.  0.99. What is the ratio of the Consumption of fixed capital (as % of GNI) of Hungary in 2002 to that in 2003?
Your answer should be compact. 1.03. What is the ratio of the Consumption of fixed capital (as % of GNI) of Latin America(developing only) in 2002 to that in 2004?
Keep it short and to the point. 0.99. What is the ratio of the Consumption of fixed capital (as % of GNI) of Austria in 2002 to that in 2004?
Make the answer very short. 1. What is the ratio of the Consumption of fixed capital (as % of GNI) of Hungary in 2002 to that in 2004?
Your response must be concise. 1.07. What is the ratio of the Consumption of fixed capital (as % of GNI) of Latin America(developing only) in 2003 to that in 2004?
Make the answer very short. 1.02. What is the ratio of the Consumption of fixed capital (as % of GNI) of Austria in 2003 to that in 2004?
Make the answer very short. 1.01. What is the ratio of the Consumption of fixed capital (as % of GNI) in Hungary in 2003 to that in 2004?
Offer a terse response. 1.03. What is the difference between the highest and the second highest Consumption of fixed capital (as % of GNI) in Latin America(developing only)?
Offer a very short reply. 0.2. What is the difference between the highest and the second highest Consumption of fixed capital (as % of GNI) of Austria?
Offer a terse response. 0.15. What is the difference between the highest and the second highest Consumption of fixed capital (as % of GNI) of Hungary?
Your response must be concise. 0.5. What is the difference between the highest and the lowest Consumption of fixed capital (as % of GNI) of Latin America(developing only)?
Provide a short and direct response. 1.39. What is the difference between the highest and the lowest Consumption of fixed capital (as % of GNI) of Austria?
Ensure brevity in your answer.  0.77. What is the difference between the highest and the lowest Consumption of fixed capital (as % of GNI) of Hungary?
Give a very brief answer. 3.85. 